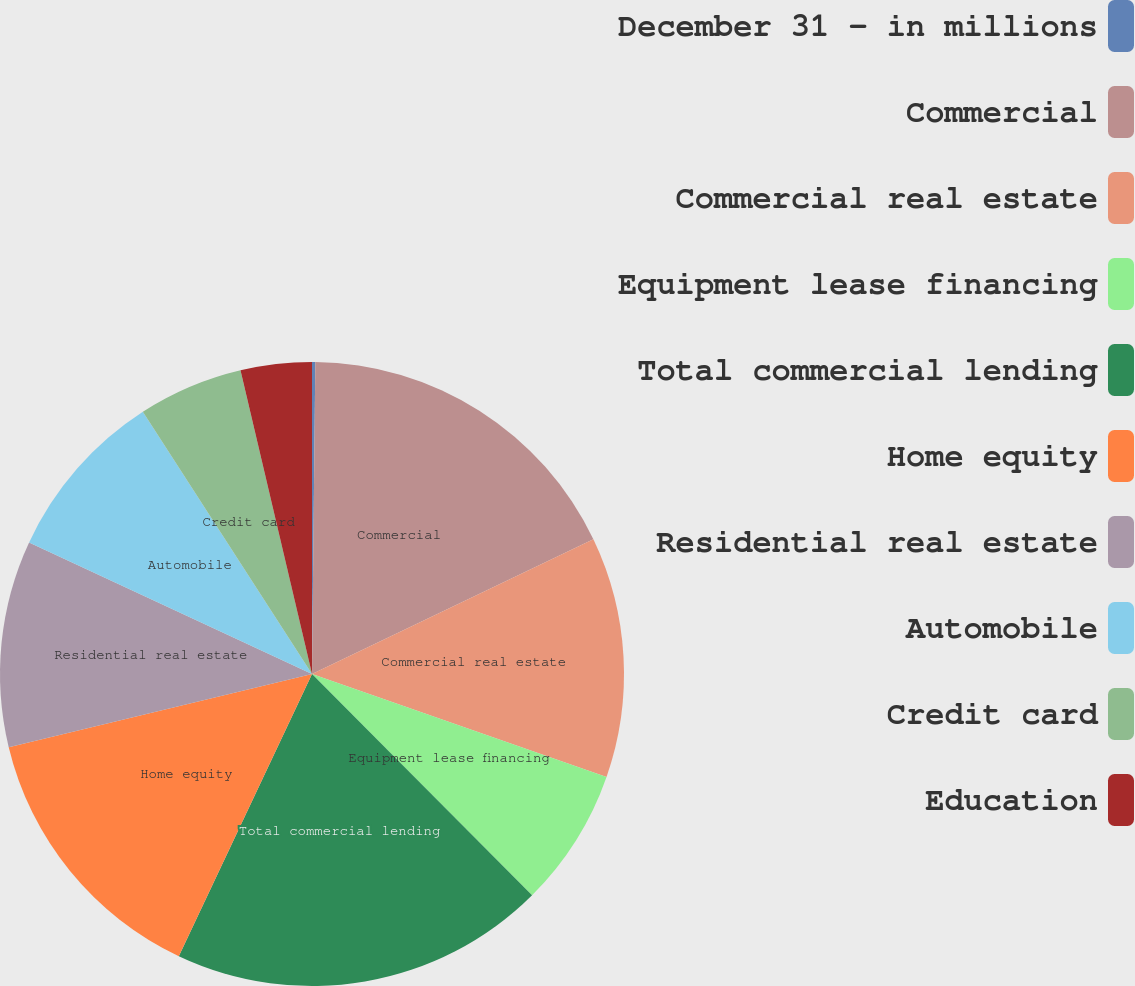<chart> <loc_0><loc_0><loc_500><loc_500><pie_chart><fcel>December 31 - in millions<fcel>Commercial<fcel>Commercial real estate<fcel>Equipment lease financing<fcel>Total commercial lending<fcel>Home equity<fcel>Residential real estate<fcel>Automobile<fcel>Credit card<fcel>Education<nl><fcel>0.17%<fcel>17.72%<fcel>12.46%<fcel>7.19%<fcel>19.48%<fcel>14.21%<fcel>10.7%<fcel>8.95%<fcel>5.44%<fcel>3.68%<nl></chart> 